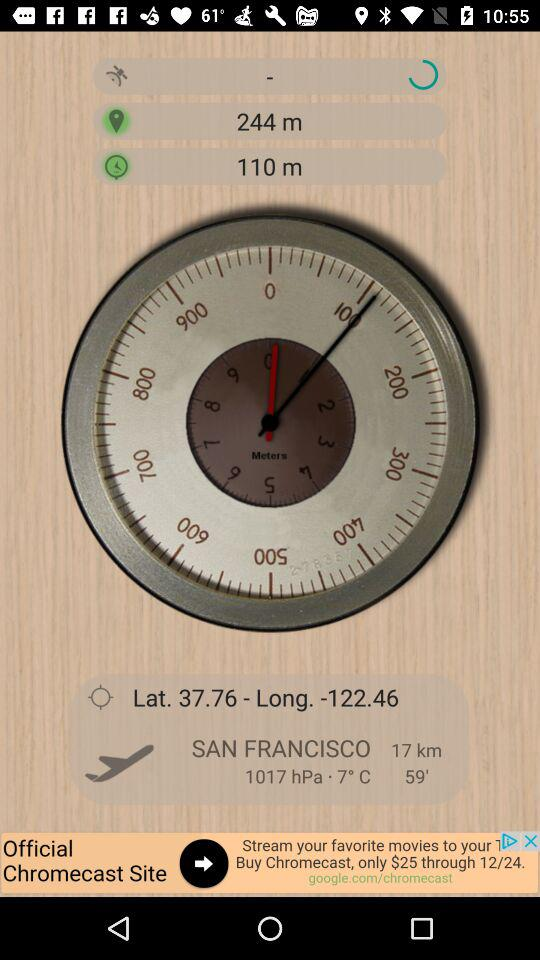What is the temperature in San Francisco?
Answer the question using a single word or phrase. 7° C 